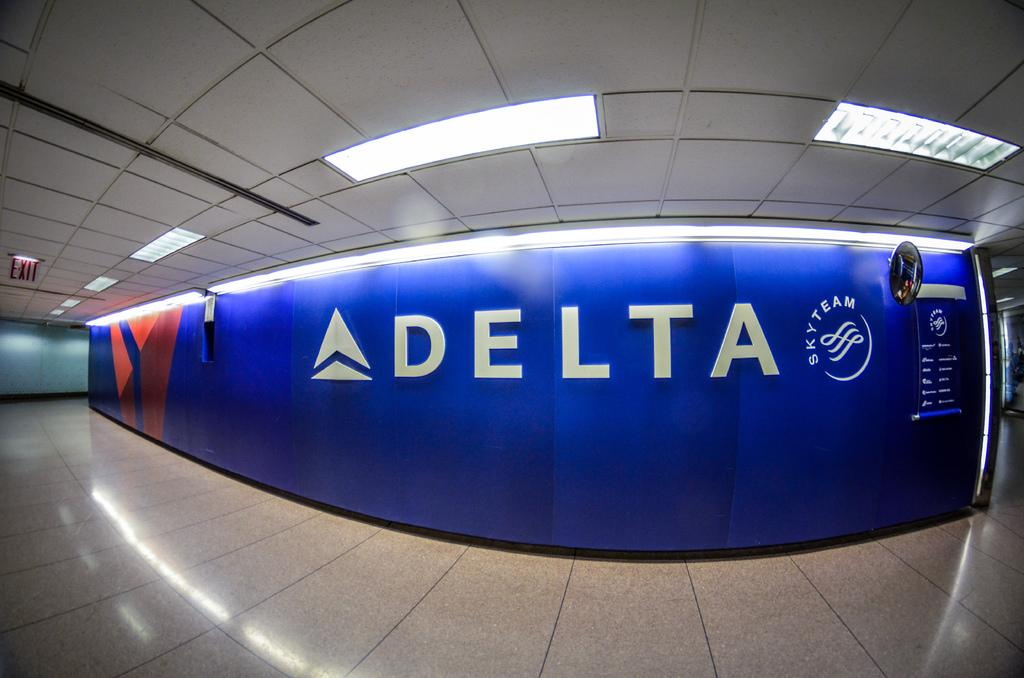What is at the bottom of the image? The image contains a floor at the bottom. What can be found on the wall in the image? There are texts written on the wall. What is located on the ceiling at the top of the image? There are lights on the ceiling at the top of the image. What type of clam is being used as a brush by the dad in the image? There is no clam, brush, or dad present in the image. 